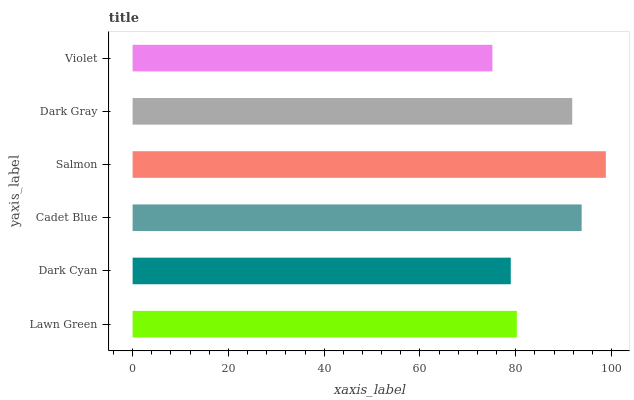Is Violet the minimum?
Answer yes or no. Yes. Is Salmon the maximum?
Answer yes or no. Yes. Is Dark Cyan the minimum?
Answer yes or no. No. Is Dark Cyan the maximum?
Answer yes or no. No. Is Lawn Green greater than Dark Cyan?
Answer yes or no. Yes. Is Dark Cyan less than Lawn Green?
Answer yes or no. Yes. Is Dark Cyan greater than Lawn Green?
Answer yes or no. No. Is Lawn Green less than Dark Cyan?
Answer yes or no. No. Is Dark Gray the high median?
Answer yes or no. Yes. Is Lawn Green the low median?
Answer yes or no. Yes. Is Violet the high median?
Answer yes or no. No. Is Cadet Blue the low median?
Answer yes or no. No. 